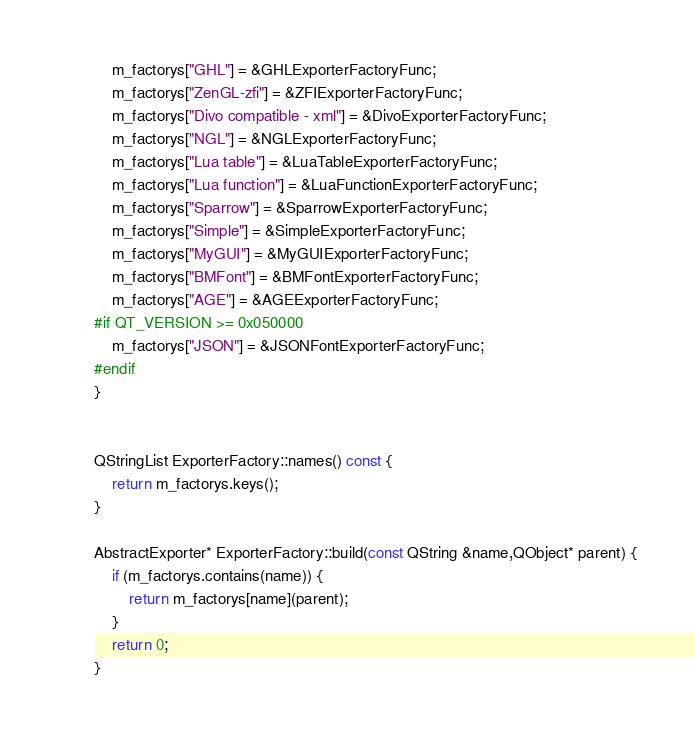Convert code to text. <code><loc_0><loc_0><loc_500><loc_500><_C++_>    m_factorys["GHL"] = &GHLExporterFactoryFunc;
    m_factorys["ZenGL-zfi"] = &ZFIExporterFactoryFunc;
    m_factorys["Divo compatible - xml"] = &DivoExporterFactoryFunc;
    m_factorys["NGL"] = &NGLExporterFactoryFunc;
    m_factorys["Lua table"] = &LuaTableExporterFactoryFunc;
    m_factorys["Lua function"] = &LuaFunctionExporterFactoryFunc;
    m_factorys["Sparrow"] = &SparrowExporterFactoryFunc;
    m_factorys["Simple"] = &SimpleExporterFactoryFunc;
    m_factorys["MyGUI"] = &MyGUIExporterFactoryFunc;
    m_factorys["BMFont"] = &BMFontExporterFactoryFunc;
    m_factorys["AGE"] = &AGEExporterFactoryFunc;
#if QT_VERSION >= 0x050000
    m_factorys["JSON"] = &JSONFontExporterFactoryFunc;
#endif
}


QStringList ExporterFactory::names() const {
    return m_factorys.keys();
}

AbstractExporter* ExporterFactory::build(const QString &name,QObject* parent) {
    if (m_factorys.contains(name)) {
        return m_factorys[name](parent);
    }
    return 0;
}
</code> 